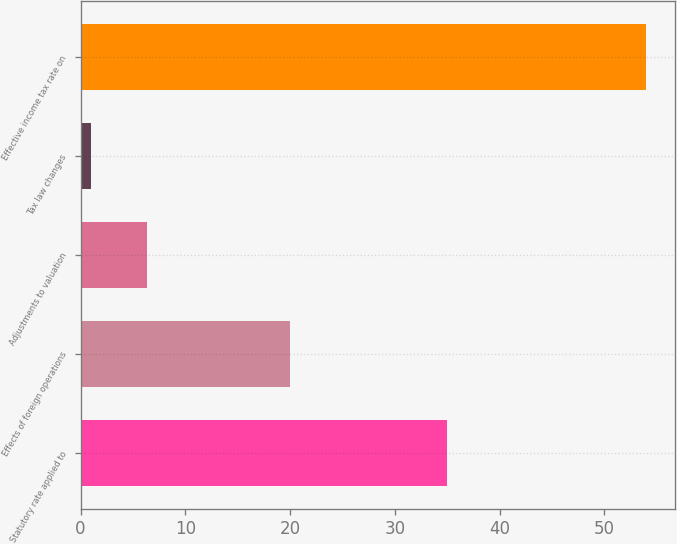Convert chart. <chart><loc_0><loc_0><loc_500><loc_500><bar_chart><fcel>Statutory rate applied to<fcel>Effects of foreign operations<fcel>Adjustments to valuation<fcel>Tax law changes<fcel>Effective income tax rate on<nl><fcel>35<fcel>20<fcel>6.3<fcel>1<fcel>54<nl></chart> 